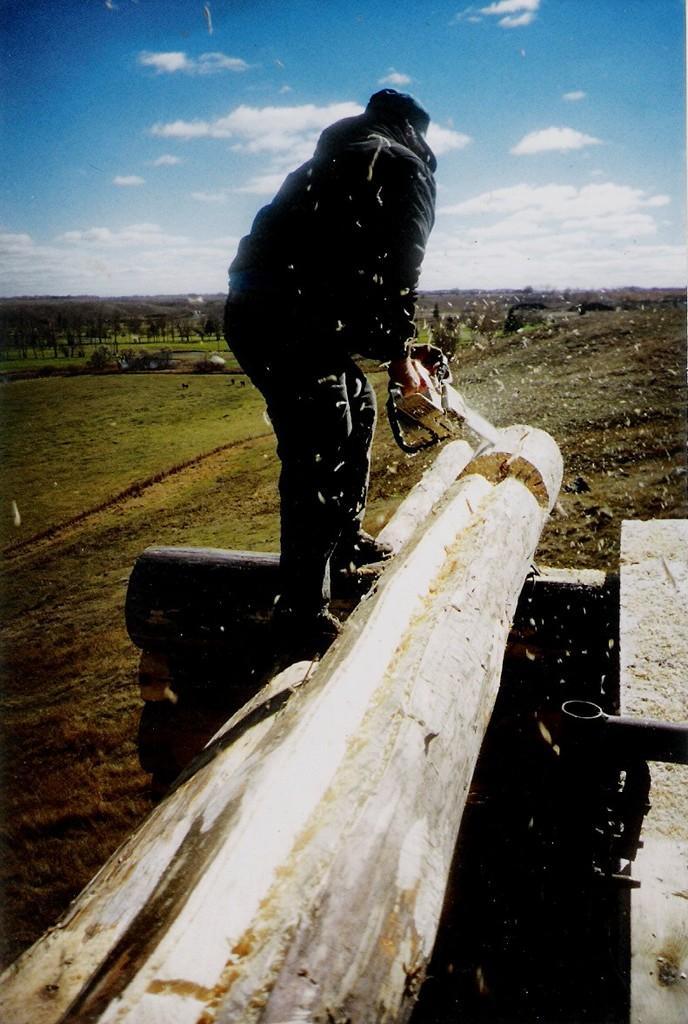Describe this image in one or two sentences. In the center of the image we can see a person sawing the wood. In the background we can see grass, trees, plants, sky and clouds. 